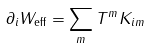<formula> <loc_0><loc_0><loc_500><loc_500>\partial _ { i } W _ { \text {eff} } = \sum _ { m } T ^ { m } K _ { i m }</formula> 